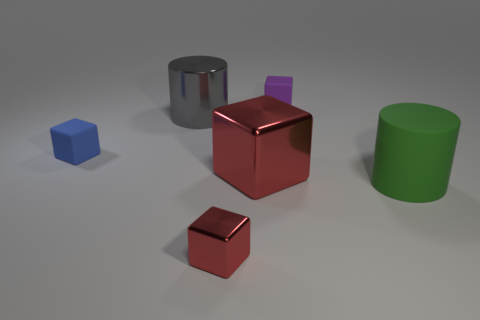Add 4 large gray cylinders. How many objects exist? 10 Subtract all cubes. How many objects are left? 2 Subtract 1 blue blocks. How many objects are left? 5 Subtract all tiny matte objects. Subtract all large cyan matte balls. How many objects are left? 4 Add 6 red shiny cubes. How many red shiny cubes are left? 8 Add 6 purple matte cylinders. How many purple matte cylinders exist? 6 